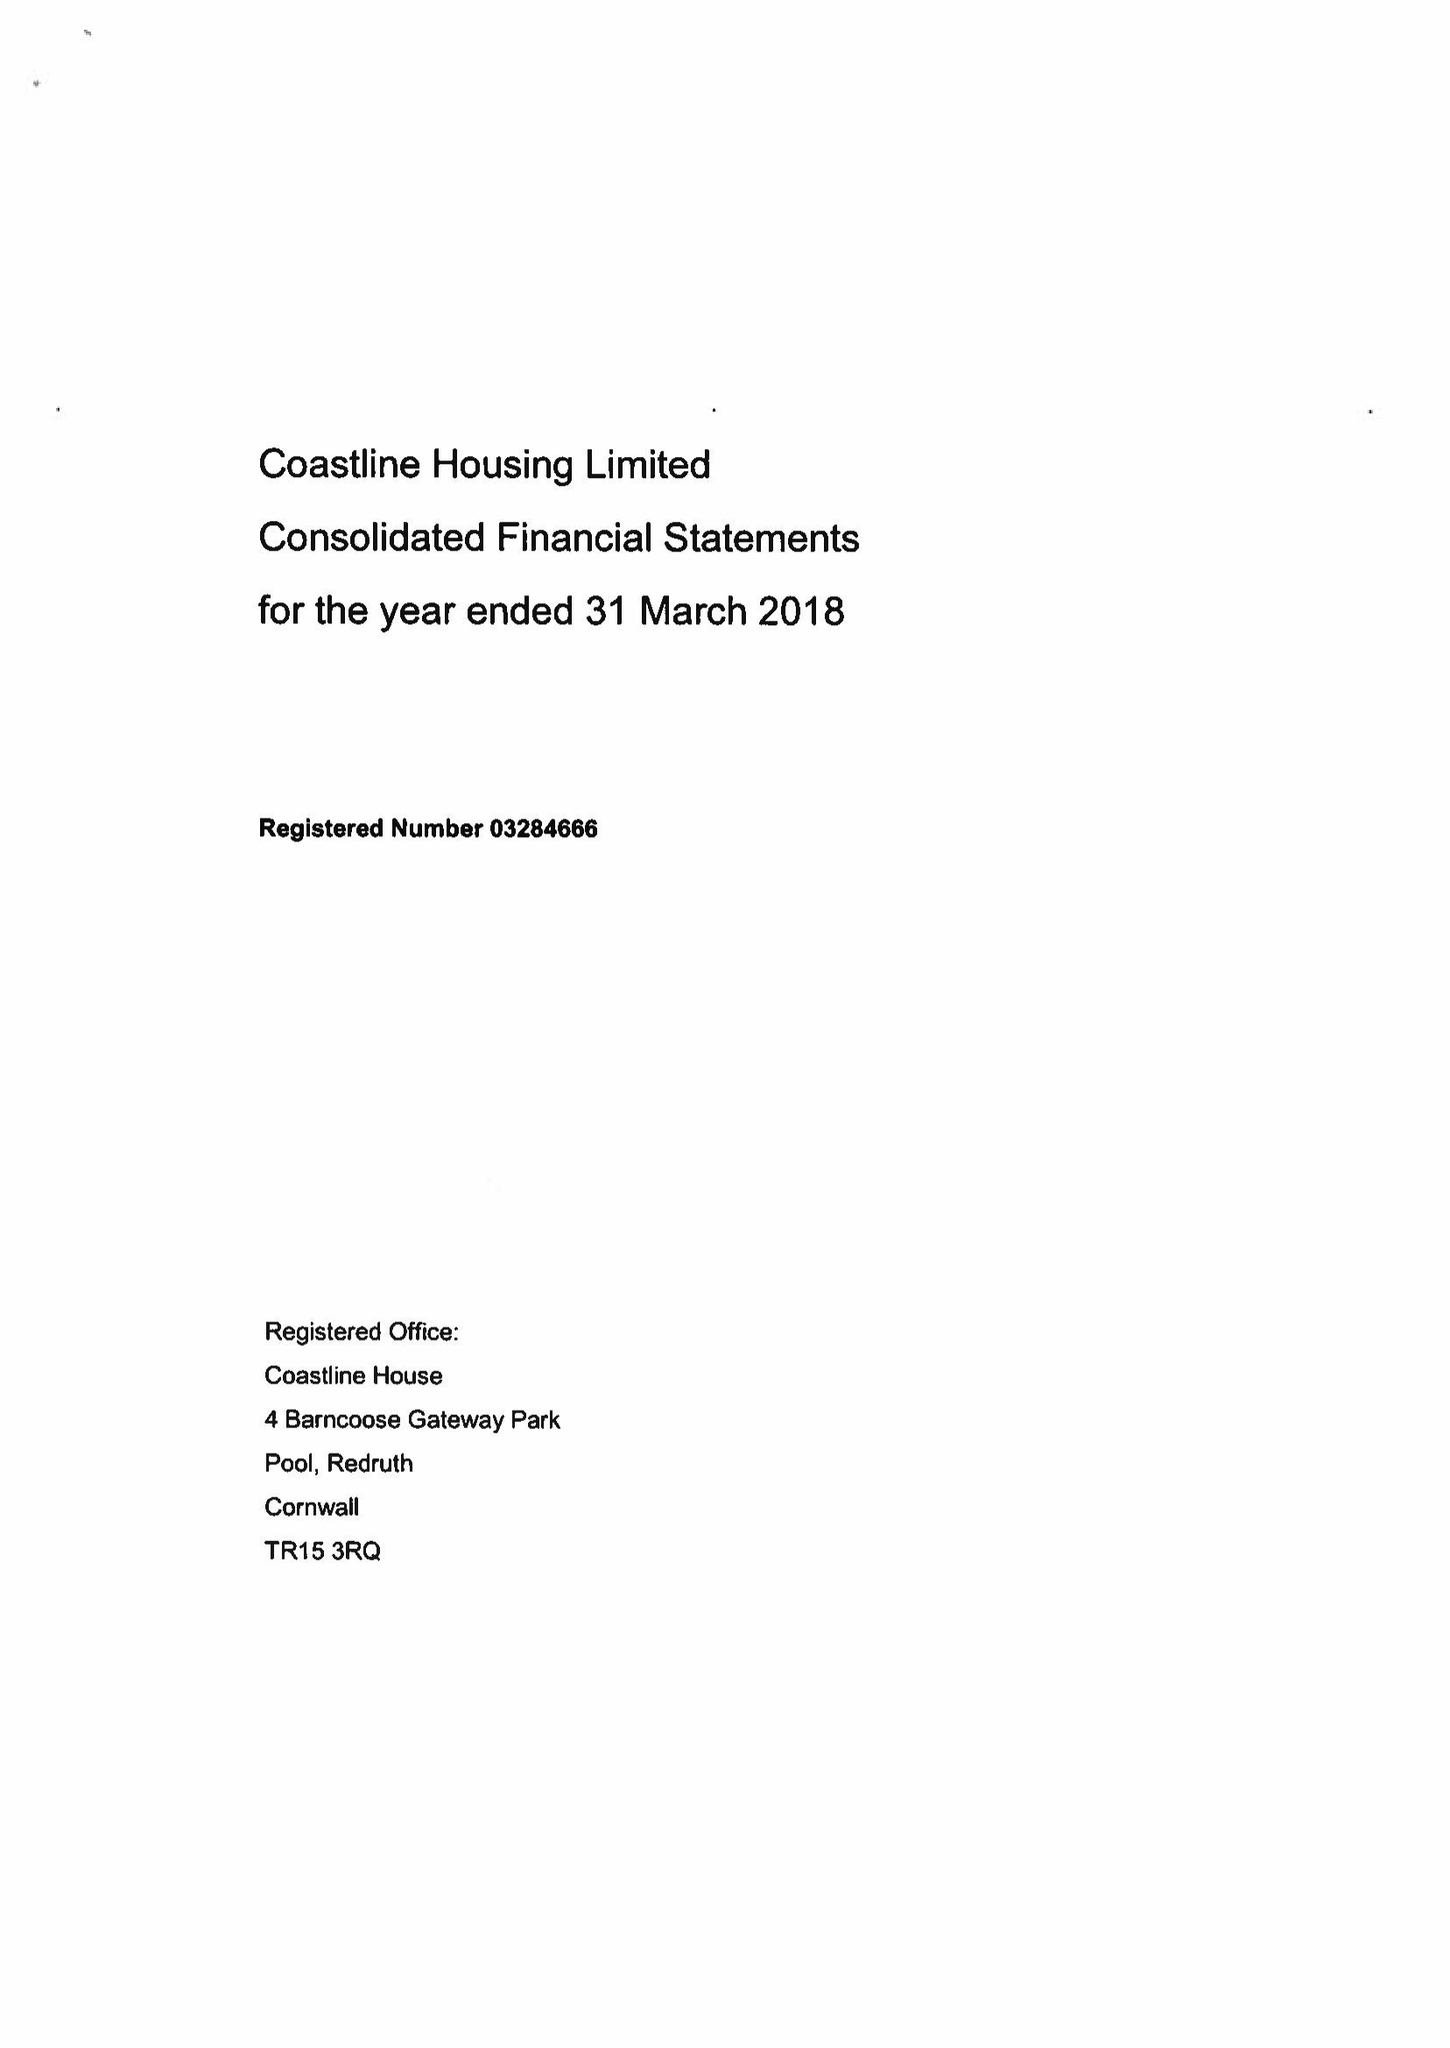What is the value for the address__postcode?
Answer the question using a single word or phrase. TR15 3RQ 